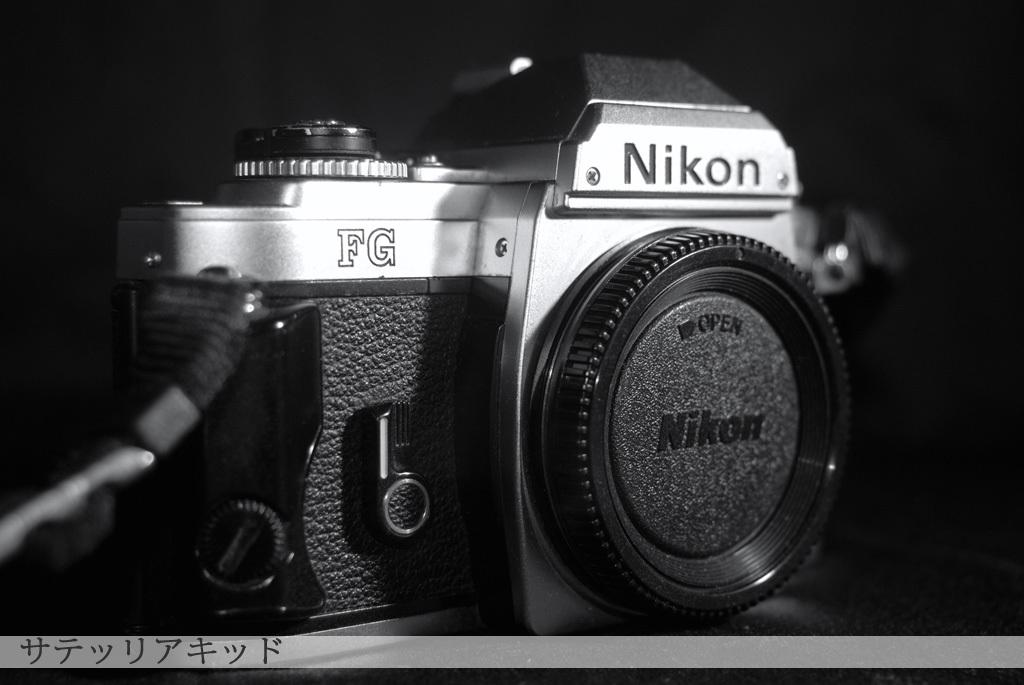What object is the main focus of the image? There is a camera in the image. Where is the camera positioned in the image? The camera is placed on a table. Can you describe the location of the camera in relation to the rest of the image? The camera is located in the center of the image. What type of reaction does the camera have when exposed to a nerve in the image? There are no reactions or nerves present in the image, as it features a camera placed on a table. 